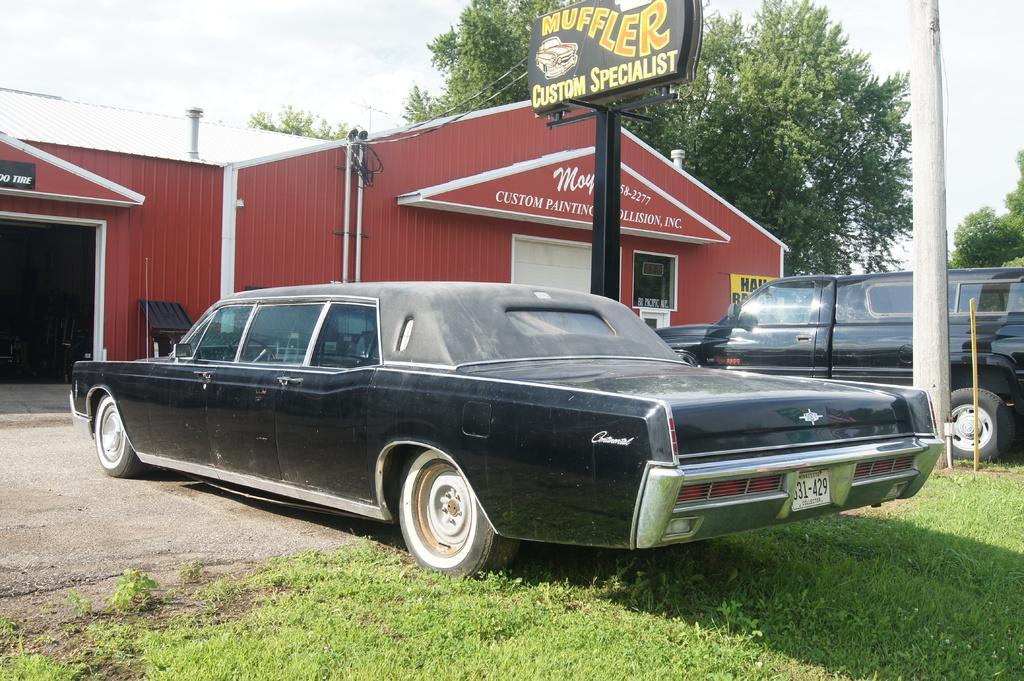Could you give a brief overview of what you see in this image? In the center of the image there are cars. There is a advertisement board. In the background of the image there is a house. There is a tree. At the top of the image there is sky. At the bottom of the image there is grass. 